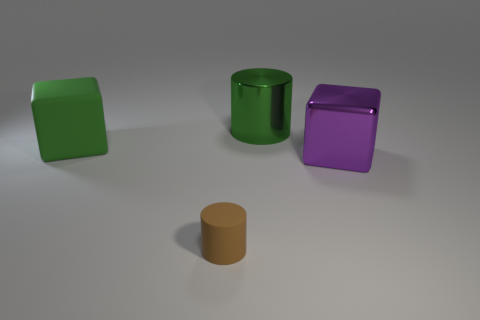Add 3 small brown cylinders. How many objects exist? 7 Subtract all tiny green rubber blocks. Subtract all purple things. How many objects are left? 3 Add 1 rubber cylinders. How many rubber cylinders are left? 2 Add 2 yellow shiny cubes. How many yellow shiny cubes exist? 2 Subtract 0 brown blocks. How many objects are left? 4 